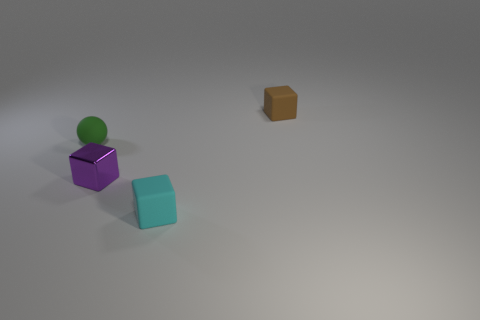What is the cube on the left side of the matte block in front of the thing behind the small green rubber object made of?
Provide a short and direct response. Metal. Is there a metallic cube that has the same size as the brown object?
Give a very brief answer. Yes. What number of brown objects are either rubber balls or rubber things?
Your answer should be compact. 1. How many tiny rubber things are the same color as the small metallic cube?
Make the answer very short. 0. Is the tiny green object made of the same material as the brown thing?
Provide a short and direct response. Yes. There is a rubber block to the right of the cyan thing; how many tiny rubber cubes are on the left side of it?
Provide a short and direct response. 1. Do the purple shiny cube and the green sphere have the same size?
Your answer should be compact. Yes. What number of green spheres have the same material as the purple thing?
Your answer should be very brief. 0. There is a purple metal thing that is the same shape as the tiny cyan object; what is its size?
Provide a short and direct response. Small. Is the shape of the rubber thing that is in front of the small green ball the same as  the purple thing?
Offer a terse response. Yes. 